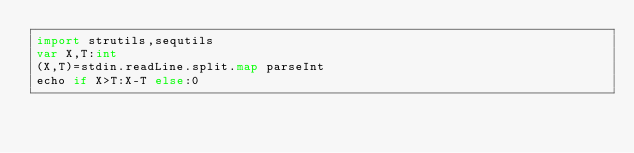<code> <loc_0><loc_0><loc_500><loc_500><_Nim_>import strutils,sequtils
var X,T:int
(X,T)=stdin.readLine.split.map parseInt
echo if X>T:X-T else:0</code> 